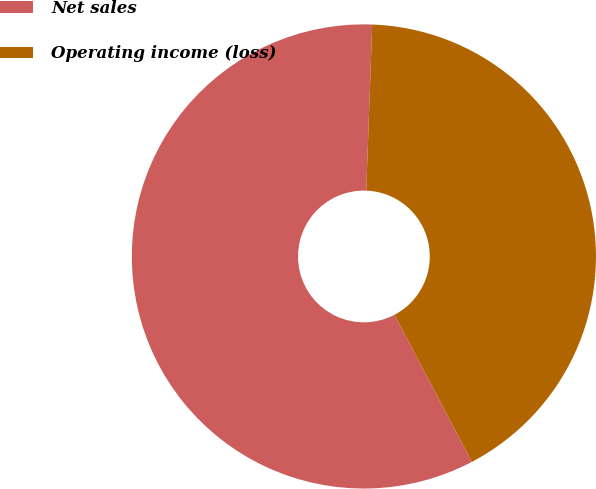Convert chart. <chart><loc_0><loc_0><loc_500><loc_500><pie_chart><fcel>Net sales<fcel>Operating income (loss)<nl><fcel>58.27%<fcel>41.73%<nl></chart> 